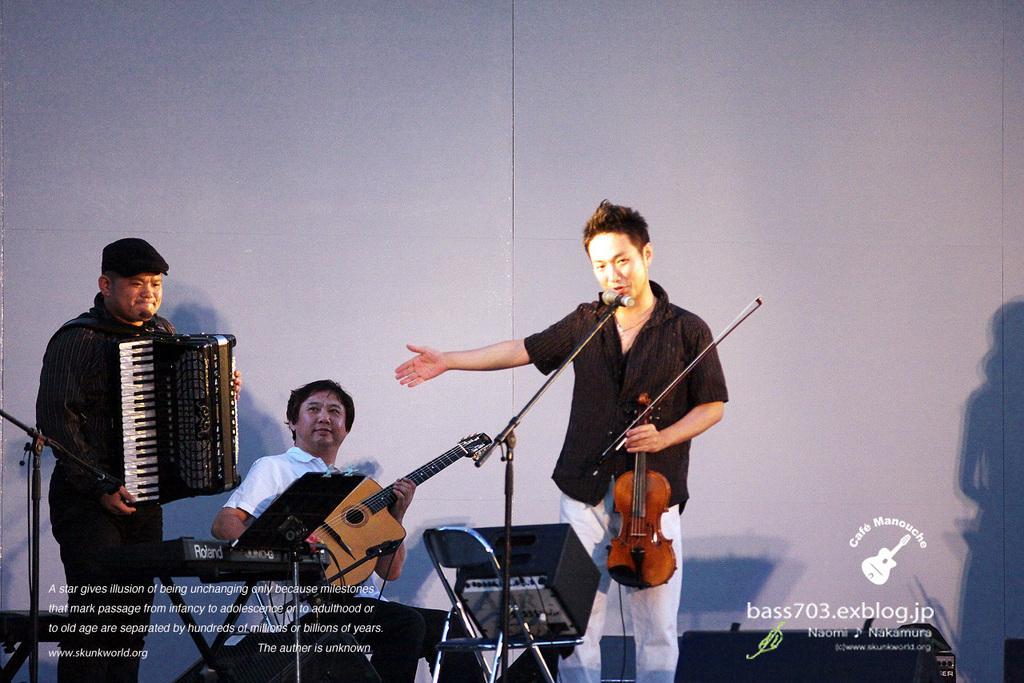Please provide a concise description of this image. There are two people standing and one person sitting. This is a piano. I can see a person holding violin and talking on the hand. Here is another person holding musical instrument. The person in the middle is playing guitar. This is the chair with a speaker on it. I can see a shadow of a woman. This looks like a poster. 